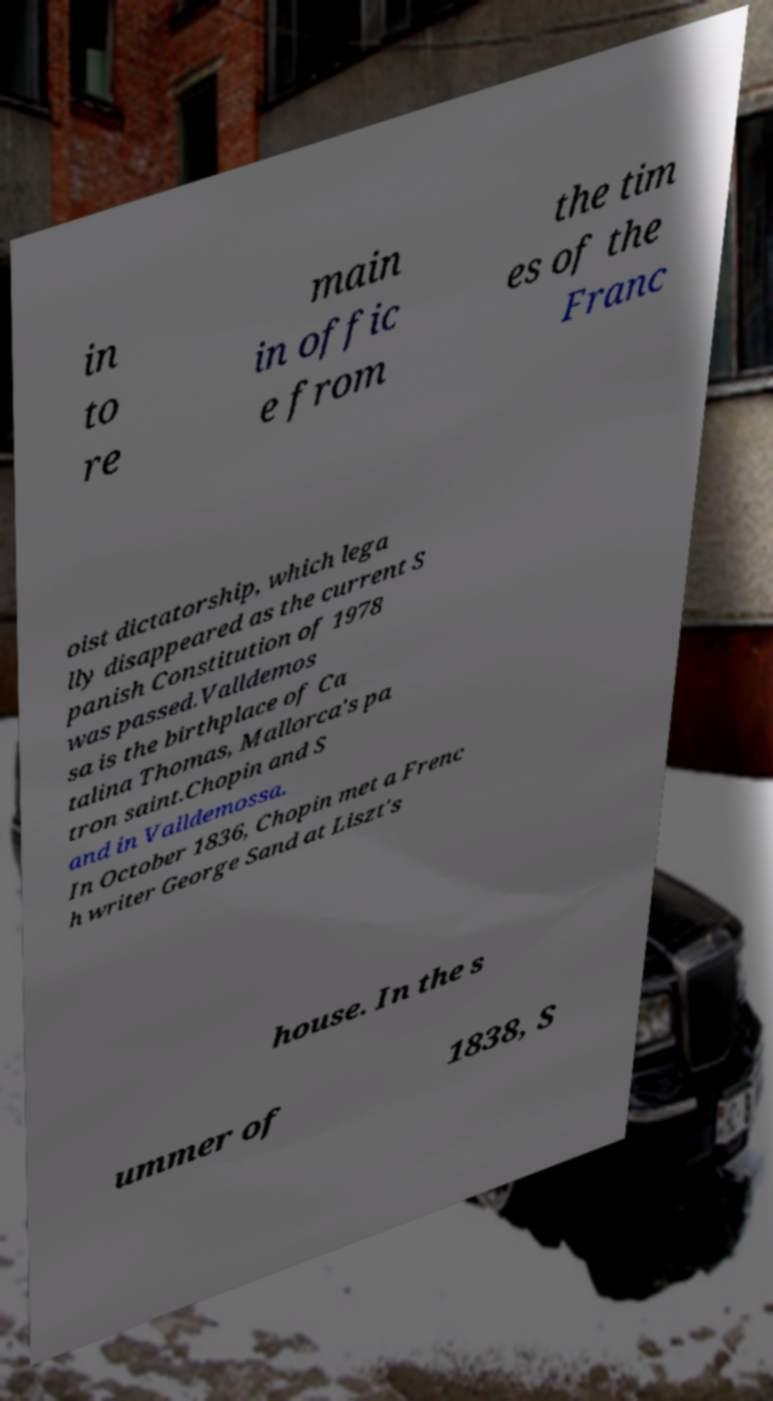What messages or text are displayed in this image? I need them in a readable, typed format. in to re main in offic e from the tim es of the Franc oist dictatorship, which lega lly disappeared as the current S panish Constitution of 1978 was passed.Valldemos sa is the birthplace of Ca talina Thomas, Mallorca's pa tron saint.Chopin and S and in Valldemossa. In October 1836, Chopin met a Frenc h writer George Sand at Liszt's house. In the s ummer of 1838, S 